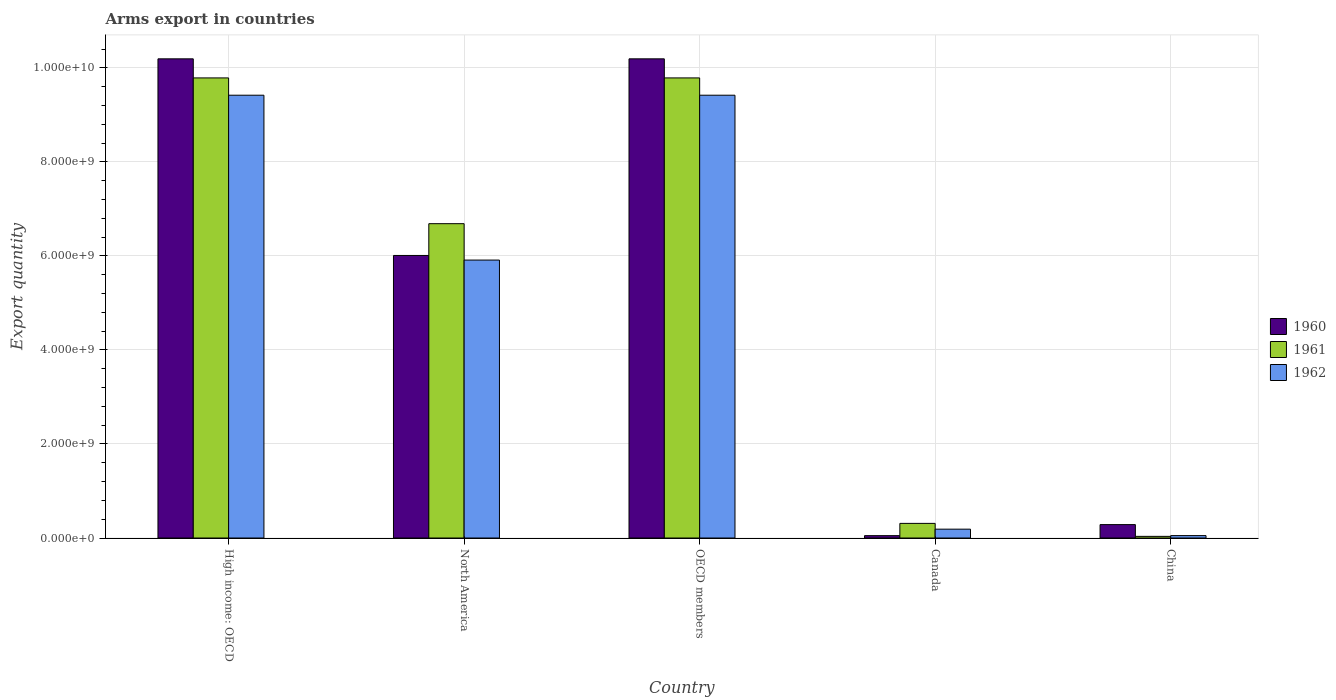How many different coloured bars are there?
Give a very brief answer. 3. Are the number of bars per tick equal to the number of legend labels?
Provide a succinct answer. Yes. How many bars are there on the 5th tick from the right?
Make the answer very short. 3. What is the label of the 1st group of bars from the left?
Your response must be concise. High income: OECD. In how many cases, is the number of bars for a given country not equal to the number of legend labels?
Give a very brief answer. 0. What is the total arms export in 1962 in OECD members?
Give a very brief answer. 9.42e+09. Across all countries, what is the maximum total arms export in 1960?
Ensure brevity in your answer.  1.02e+1. Across all countries, what is the minimum total arms export in 1961?
Provide a succinct answer. 3.50e+07. In which country was the total arms export in 1960 maximum?
Ensure brevity in your answer.  High income: OECD. In which country was the total arms export in 1962 minimum?
Offer a very short reply. China. What is the total total arms export in 1962 in the graph?
Ensure brevity in your answer.  2.50e+1. What is the difference between the total arms export in 1962 in Canada and that in High income: OECD?
Offer a terse response. -9.23e+09. What is the difference between the total arms export in 1962 in OECD members and the total arms export in 1960 in High income: OECD?
Keep it short and to the point. -7.74e+08. What is the average total arms export in 1960 per country?
Your response must be concise. 5.35e+09. What is the difference between the total arms export of/in 1962 and total arms export of/in 1960 in OECD members?
Provide a short and direct response. -7.74e+08. What is the ratio of the total arms export in 1962 in Canada to that in North America?
Offer a terse response. 0.03. Is the total arms export in 1961 in Canada less than that in OECD members?
Make the answer very short. Yes. Is the difference between the total arms export in 1962 in China and OECD members greater than the difference between the total arms export in 1960 in China and OECD members?
Keep it short and to the point. Yes. What is the difference between the highest and the second highest total arms export in 1962?
Provide a succinct answer. 3.51e+09. What is the difference between the highest and the lowest total arms export in 1960?
Provide a succinct answer. 1.01e+1. What does the 1st bar from the left in OECD members represents?
Provide a succinct answer. 1960. What does the 2nd bar from the right in China represents?
Provide a short and direct response. 1961. Is it the case that in every country, the sum of the total arms export in 1961 and total arms export in 1960 is greater than the total arms export in 1962?
Keep it short and to the point. Yes. How many countries are there in the graph?
Provide a short and direct response. 5. What is the difference between two consecutive major ticks on the Y-axis?
Your response must be concise. 2.00e+09. Are the values on the major ticks of Y-axis written in scientific E-notation?
Provide a succinct answer. Yes. Does the graph contain grids?
Provide a short and direct response. Yes. Where does the legend appear in the graph?
Make the answer very short. Center right. What is the title of the graph?
Your response must be concise. Arms export in countries. Does "1992" appear as one of the legend labels in the graph?
Offer a terse response. No. What is the label or title of the Y-axis?
Keep it short and to the point. Export quantity. What is the Export quantity of 1960 in High income: OECD?
Your response must be concise. 1.02e+1. What is the Export quantity in 1961 in High income: OECD?
Your response must be concise. 9.79e+09. What is the Export quantity in 1962 in High income: OECD?
Provide a succinct answer. 9.42e+09. What is the Export quantity of 1960 in North America?
Make the answer very short. 6.01e+09. What is the Export quantity in 1961 in North America?
Your answer should be very brief. 6.69e+09. What is the Export quantity in 1962 in North America?
Make the answer very short. 5.91e+09. What is the Export quantity in 1960 in OECD members?
Provide a short and direct response. 1.02e+1. What is the Export quantity of 1961 in OECD members?
Your answer should be very brief. 9.79e+09. What is the Export quantity in 1962 in OECD members?
Ensure brevity in your answer.  9.42e+09. What is the Export quantity in 1961 in Canada?
Keep it short and to the point. 3.11e+08. What is the Export quantity of 1962 in Canada?
Your answer should be very brief. 1.88e+08. What is the Export quantity of 1960 in China?
Ensure brevity in your answer.  2.85e+08. What is the Export quantity of 1961 in China?
Make the answer very short. 3.50e+07. What is the Export quantity of 1962 in China?
Provide a succinct answer. 5.10e+07. Across all countries, what is the maximum Export quantity of 1960?
Keep it short and to the point. 1.02e+1. Across all countries, what is the maximum Export quantity of 1961?
Ensure brevity in your answer.  9.79e+09. Across all countries, what is the maximum Export quantity of 1962?
Offer a very short reply. 9.42e+09. Across all countries, what is the minimum Export quantity in 1960?
Offer a terse response. 5.00e+07. Across all countries, what is the minimum Export quantity in 1961?
Make the answer very short. 3.50e+07. Across all countries, what is the minimum Export quantity of 1962?
Offer a very short reply. 5.10e+07. What is the total Export quantity of 1960 in the graph?
Your response must be concise. 2.67e+1. What is the total Export quantity of 1961 in the graph?
Offer a very short reply. 2.66e+1. What is the total Export quantity in 1962 in the graph?
Offer a very short reply. 2.50e+1. What is the difference between the Export quantity in 1960 in High income: OECD and that in North America?
Your answer should be very brief. 4.18e+09. What is the difference between the Export quantity in 1961 in High income: OECD and that in North America?
Make the answer very short. 3.10e+09. What is the difference between the Export quantity in 1962 in High income: OECD and that in North America?
Keep it short and to the point. 3.51e+09. What is the difference between the Export quantity of 1960 in High income: OECD and that in OECD members?
Offer a very short reply. 0. What is the difference between the Export quantity in 1960 in High income: OECD and that in Canada?
Make the answer very short. 1.01e+1. What is the difference between the Export quantity in 1961 in High income: OECD and that in Canada?
Offer a very short reply. 9.48e+09. What is the difference between the Export quantity of 1962 in High income: OECD and that in Canada?
Offer a terse response. 9.23e+09. What is the difference between the Export quantity of 1960 in High income: OECD and that in China?
Offer a terse response. 9.91e+09. What is the difference between the Export quantity of 1961 in High income: OECD and that in China?
Offer a terse response. 9.75e+09. What is the difference between the Export quantity of 1962 in High income: OECD and that in China?
Your response must be concise. 9.37e+09. What is the difference between the Export quantity of 1960 in North America and that in OECD members?
Keep it short and to the point. -4.18e+09. What is the difference between the Export quantity of 1961 in North America and that in OECD members?
Your response must be concise. -3.10e+09. What is the difference between the Export quantity in 1962 in North America and that in OECD members?
Offer a very short reply. -3.51e+09. What is the difference between the Export quantity of 1960 in North America and that in Canada?
Ensure brevity in your answer.  5.96e+09. What is the difference between the Export quantity in 1961 in North America and that in Canada?
Keep it short and to the point. 6.38e+09. What is the difference between the Export quantity of 1962 in North America and that in Canada?
Provide a succinct answer. 5.72e+09. What is the difference between the Export quantity of 1960 in North America and that in China?
Keep it short and to the point. 5.73e+09. What is the difference between the Export quantity in 1961 in North America and that in China?
Offer a very short reply. 6.65e+09. What is the difference between the Export quantity of 1962 in North America and that in China?
Give a very brief answer. 5.86e+09. What is the difference between the Export quantity of 1960 in OECD members and that in Canada?
Provide a succinct answer. 1.01e+1. What is the difference between the Export quantity in 1961 in OECD members and that in Canada?
Make the answer very short. 9.48e+09. What is the difference between the Export quantity of 1962 in OECD members and that in Canada?
Provide a short and direct response. 9.23e+09. What is the difference between the Export quantity of 1960 in OECD members and that in China?
Keep it short and to the point. 9.91e+09. What is the difference between the Export quantity in 1961 in OECD members and that in China?
Provide a succinct answer. 9.75e+09. What is the difference between the Export quantity of 1962 in OECD members and that in China?
Keep it short and to the point. 9.37e+09. What is the difference between the Export quantity of 1960 in Canada and that in China?
Your answer should be very brief. -2.35e+08. What is the difference between the Export quantity in 1961 in Canada and that in China?
Your response must be concise. 2.76e+08. What is the difference between the Export quantity of 1962 in Canada and that in China?
Make the answer very short. 1.37e+08. What is the difference between the Export quantity in 1960 in High income: OECD and the Export quantity in 1961 in North America?
Your answer should be compact. 3.51e+09. What is the difference between the Export quantity of 1960 in High income: OECD and the Export quantity of 1962 in North America?
Give a very brief answer. 4.28e+09. What is the difference between the Export quantity in 1961 in High income: OECD and the Export quantity in 1962 in North America?
Ensure brevity in your answer.  3.88e+09. What is the difference between the Export quantity of 1960 in High income: OECD and the Export quantity of 1961 in OECD members?
Your answer should be compact. 4.06e+08. What is the difference between the Export quantity in 1960 in High income: OECD and the Export quantity in 1962 in OECD members?
Offer a very short reply. 7.74e+08. What is the difference between the Export quantity of 1961 in High income: OECD and the Export quantity of 1962 in OECD members?
Your answer should be compact. 3.68e+08. What is the difference between the Export quantity in 1960 in High income: OECD and the Export quantity in 1961 in Canada?
Keep it short and to the point. 9.88e+09. What is the difference between the Export quantity of 1960 in High income: OECD and the Export quantity of 1962 in Canada?
Give a very brief answer. 1.00e+1. What is the difference between the Export quantity of 1961 in High income: OECD and the Export quantity of 1962 in Canada?
Your answer should be very brief. 9.60e+09. What is the difference between the Export quantity in 1960 in High income: OECD and the Export quantity in 1961 in China?
Make the answer very short. 1.02e+1. What is the difference between the Export quantity in 1960 in High income: OECD and the Export quantity in 1962 in China?
Your answer should be very brief. 1.01e+1. What is the difference between the Export quantity of 1961 in High income: OECD and the Export quantity of 1962 in China?
Give a very brief answer. 9.74e+09. What is the difference between the Export quantity in 1960 in North America and the Export quantity in 1961 in OECD members?
Provide a short and direct response. -3.78e+09. What is the difference between the Export quantity in 1960 in North America and the Export quantity in 1962 in OECD members?
Provide a short and direct response. -3.41e+09. What is the difference between the Export quantity in 1961 in North America and the Export quantity in 1962 in OECD members?
Your response must be concise. -2.73e+09. What is the difference between the Export quantity of 1960 in North America and the Export quantity of 1961 in Canada?
Your answer should be compact. 5.70e+09. What is the difference between the Export quantity of 1960 in North America and the Export quantity of 1962 in Canada?
Keep it short and to the point. 5.82e+09. What is the difference between the Export quantity of 1961 in North America and the Export quantity of 1962 in Canada?
Provide a succinct answer. 6.50e+09. What is the difference between the Export quantity in 1960 in North America and the Export quantity in 1961 in China?
Make the answer very short. 5.98e+09. What is the difference between the Export quantity in 1960 in North America and the Export quantity in 1962 in China?
Provide a succinct answer. 5.96e+09. What is the difference between the Export quantity in 1961 in North America and the Export quantity in 1962 in China?
Make the answer very short. 6.64e+09. What is the difference between the Export quantity in 1960 in OECD members and the Export quantity in 1961 in Canada?
Give a very brief answer. 9.88e+09. What is the difference between the Export quantity in 1960 in OECD members and the Export quantity in 1962 in Canada?
Give a very brief answer. 1.00e+1. What is the difference between the Export quantity in 1961 in OECD members and the Export quantity in 1962 in Canada?
Offer a very short reply. 9.60e+09. What is the difference between the Export quantity of 1960 in OECD members and the Export quantity of 1961 in China?
Offer a very short reply. 1.02e+1. What is the difference between the Export quantity in 1960 in OECD members and the Export quantity in 1962 in China?
Offer a very short reply. 1.01e+1. What is the difference between the Export quantity in 1961 in OECD members and the Export quantity in 1962 in China?
Your response must be concise. 9.74e+09. What is the difference between the Export quantity of 1960 in Canada and the Export quantity of 1961 in China?
Make the answer very short. 1.50e+07. What is the difference between the Export quantity of 1961 in Canada and the Export quantity of 1962 in China?
Provide a short and direct response. 2.60e+08. What is the average Export quantity of 1960 per country?
Provide a succinct answer. 5.35e+09. What is the average Export quantity of 1961 per country?
Your answer should be compact. 5.32e+09. What is the average Export quantity of 1962 per country?
Give a very brief answer. 5.00e+09. What is the difference between the Export quantity in 1960 and Export quantity in 1961 in High income: OECD?
Make the answer very short. 4.06e+08. What is the difference between the Export quantity of 1960 and Export quantity of 1962 in High income: OECD?
Keep it short and to the point. 7.74e+08. What is the difference between the Export quantity in 1961 and Export quantity in 1962 in High income: OECD?
Give a very brief answer. 3.68e+08. What is the difference between the Export quantity in 1960 and Export quantity in 1961 in North America?
Make the answer very short. -6.76e+08. What is the difference between the Export quantity in 1960 and Export quantity in 1962 in North America?
Offer a very short reply. 9.80e+07. What is the difference between the Export quantity of 1961 and Export quantity of 1962 in North America?
Your response must be concise. 7.74e+08. What is the difference between the Export quantity of 1960 and Export quantity of 1961 in OECD members?
Provide a short and direct response. 4.06e+08. What is the difference between the Export quantity in 1960 and Export quantity in 1962 in OECD members?
Offer a very short reply. 7.74e+08. What is the difference between the Export quantity of 1961 and Export quantity of 1962 in OECD members?
Your answer should be compact. 3.68e+08. What is the difference between the Export quantity in 1960 and Export quantity in 1961 in Canada?
Offer a terse response. -2.61e+08. What is the difference between the Export quantity in 1960 and Export quantity in 1962 in Canada?
Keep it short and to the point. -1.38e+08. What is the difference between the Export quantity in 1961 and Export quantity in 1962 in Canada?
Your response must be concise. 1.23e+08. What is the difference between the Export quantity of 1960 and Export quantity of 1961 in China?
Keep it short and to the point. 2.50e+08. What is the difference between the Export quantity of 1960 and Export quantity of 1962 in China?
Your response must be concise. 2.34e+08. What is the difference between the Export quantity in 1961 and Export quantity in 1962 in China?
Offer a very short reply. -1.60e+07. What is the ratio of the Export quantity of 1960 in High income: OECD to that in North America?
Offer a very short reply. 1.7. What is the ratio of the Export quantity in 1961 in High income: OECD to that in North America?
Offer a terse response. 1.46. What is the ratio of the Export quantity of 1962 in High income: OECD to that in North America?
Offer a terse response. 1.59. What is the ratio of the Export quantity in 1960 in High income: OECD to that in Canada?
Make the answer very short. 203.88. What is the ratio of the Export quantity in 1961 in High income: OECD to that in Canada?
Keep it short and to the point. 31.47. What is the ratio of the Export quantity of 1962 in High income: OECD to that in Canada?
Your answer should be compact. 50.11. What is the ratio of the Export quantity of 1960 in High income: OECD to that in China?
Give a very brief answer. 35.77. What is the ratio of the Export quantity in 1961 in High income: OECD to that in China?
Make the answer very short. 279.66. What is the ratio of the Export quantity in 1962 in High income: OECD to that in China?
Ensure brevity in your answer.  184.71. What is the ratio of the Export quantity of 1960 in North America to that in OECD members?
Ensure brevity in your answer.  0.59. What is the ratio of the Export quantity in 1961 in North America to that in OECD members?
Make the answer very short. 0.68. What is the ratio of the Export quantity in 1962 in North America to that in OECD members?
Offer a very short reply. 0.63. What is the ratio of the Export quantity of 1960 in North America to that in Canada?
Provide a short and direct response. 120.22. What is the ratio of the Export quantity in 1961 in North America to that in Canada?
Offer a very short reply. 21.5. What is the ratio of the Export quantity in 1962 in North America to that in Canada?
Ensure brevity in your answer.  31.45. What is the ratio of the Export quantity in 1960 in North America to that in China?
Provide a succinct answer. 21.09. What is the ratio of the Export quantity of 1961 in North America to that in China?
Offer a terse response. 191.06. What is the ratio of the Export quantity in 1962 in North America to that in China?
Keep it short and to the point. 115.94. What is the ratio of the Export quantity of 1960 in OECD members to that in Canada?
Keep it short and to the point. 203.88. What is the ratio of the Export quantity of 1961 in OECD members to that in Canada?
Offer a terse response. 31.47. What is the ratio of the Export quantity of 1962 in OECD members to that in Canada?
Ensure brevity in your answer.  50.11. What is the ratio of the Export quantity of 1960 in OECD members to that in China?
Provide a succinct answer. 35.77. What is the ratio of the Export quantity in 1961 in OECD members to that in China?
Offer a very short reply. 279.66. What is the ratio of the Export quantity in 1962 in OECD members to that in China?
Make the answer very short. 184.71. What is the ratio of the Export quantity of 1960 in Canada to that in China?
Offer a terse response. 0.18. What is the ratio of the Export quantity of 1961 in Canada to that in China?
Your answer should be very brief. 8.89. What is the ratio of the Export quantity of 1962 in Canada to that in China?
Ensure brevity in your answer.  3.69. What is the difference between the highest and the second highest Export quantity of 1962?
Ensure brevity in your answer.  0. What is the difference between the highest and the lowest Export quantity of 1960?
Ensure brevity in your answer.  1.01e+1. What is the difference between the highest and the lowest Export quantity of 1961?
Provide a short and direct response. 9.75e+09. What is the difference between the highest and the lowest Export quantity in 1962?
Provide a succinct answer. 9.37e+09. 